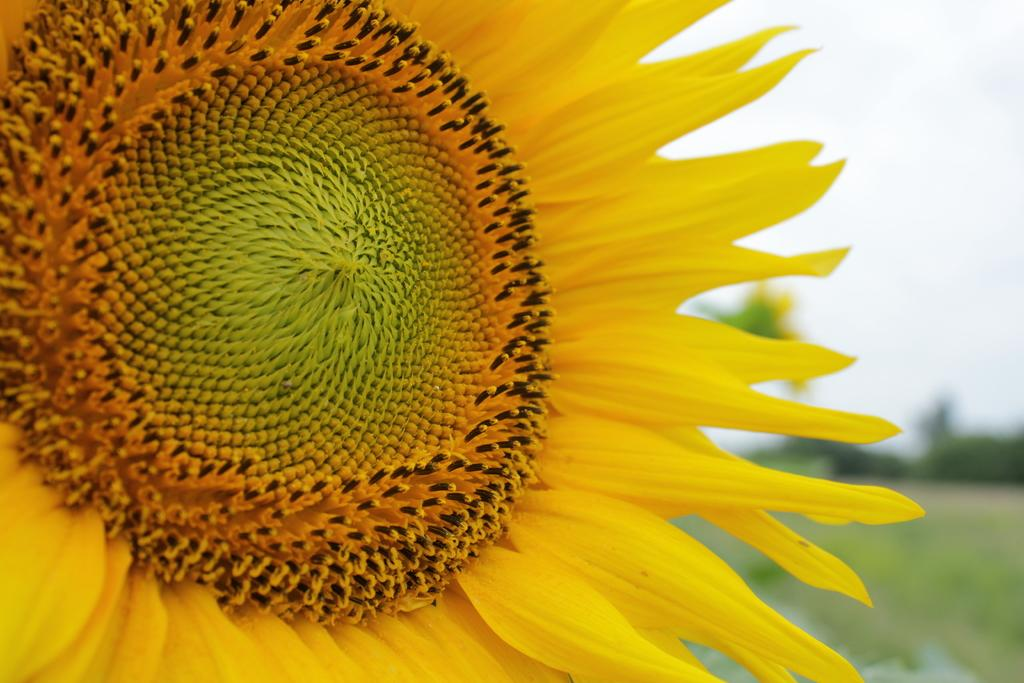What is the main subject of the image? There is a flower in the image. How would you describe the background of the image? The background of the image is blurred. Can you see any part of the sky in the image? Yes, the sky is visible in the top right corner of the image. Where is the library located in the image? There is no library present in the image; it features a flower and a blurred background. Can you see a throne in the image? There is no throne present in the image. 